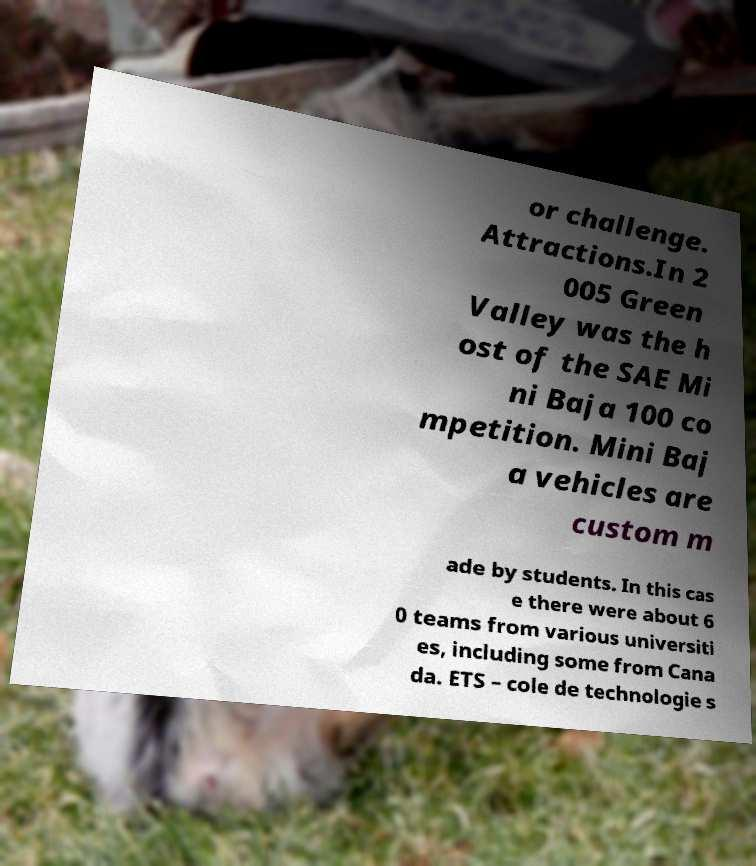For documentation purposes, I need the text within this image transcribed. Could you provide that? or challenge. Attractions.In 2 005 Green Valley was the h ost of the SAE Mi ni Baja 100 co mpetition. Mini Baj a vehicles are custom m ade by students. In this cas e there were about 6 0 teams from various universiti es, including some from Cana da. ETS – cole de technologie s 